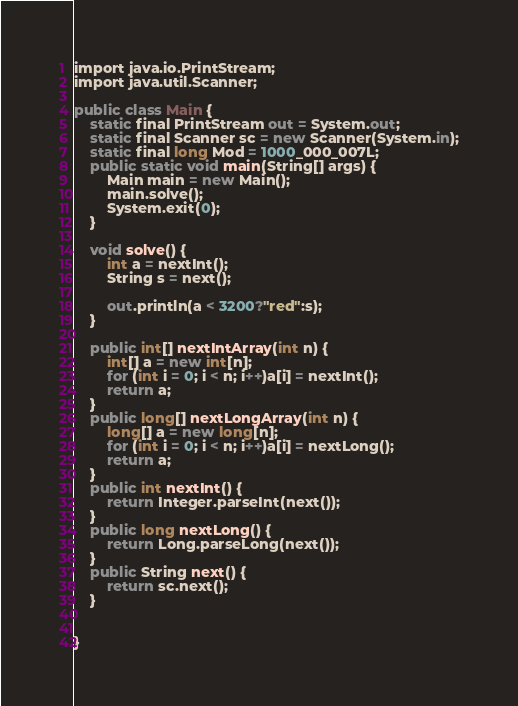Convert code to text. <code><loc_0><loc_0><loc_500><loc_500><_C#_>import java.io.PrintStream;
import java.util.Scanner;

public class Main {
	static final PrintStream out = System.out;
	static final Scanner sc = new Scanner(System.in);
	static final long Mod = 1000_000_007L;
	public static void main(String[] args) {
		Main main = new Main();
		main.solve();
		System.exit(0);
	}

	void solve() {
		int a = nextInt();
		String s = next();

		out.println(a < 3200?"red":s);
	}

	public int[] nextIntArray(int n) {
		int[] a = new int[n];
		for (int i = 0; i < n; i++)a[i] = nextInt();
		return a;
	}
	public long[] nextLongArray(int n) {
		long[] a = new long[n];
		for (int i = 0; i < n; i++)a[i] = nextLong();
		return a;
	}
	public int nextInt() {
		return Integer.parseInt(next());
	}
	public long nextLong() {
		return Long.parseLong(next());
	}
	public String next() {
		return sc.next();
	}


}</code> 